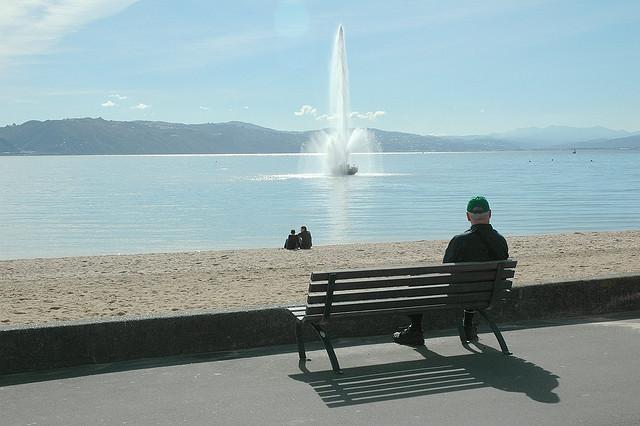Is the person reading?
Write a very short answer. No. Are there mountains in the landscape?
Answer briefly. Yes. What are the striped containers used for?
Give a very brief answer. Sitting. What is the predominant color?
Keep it brief. Blue. How many benches are on the beach?
Short answer required. 1. What are those guys doing?
Give a very brief answer. Sitting. What is the bench bolted to?
Give a very brief answer. Ground. How many people are sitting at the water edge?
Quick response, please. 2. Is the water in the lake clean?
Concise answer only. Yes. How many living creatures are present?
Be succinct. 3. What is sticking out of the water?
Short answer required. Fountain. Is there a fountain in this photo?
Short answer required. Yes. How many of the people on the closest bench are talking?
Keep it brief. 0. 